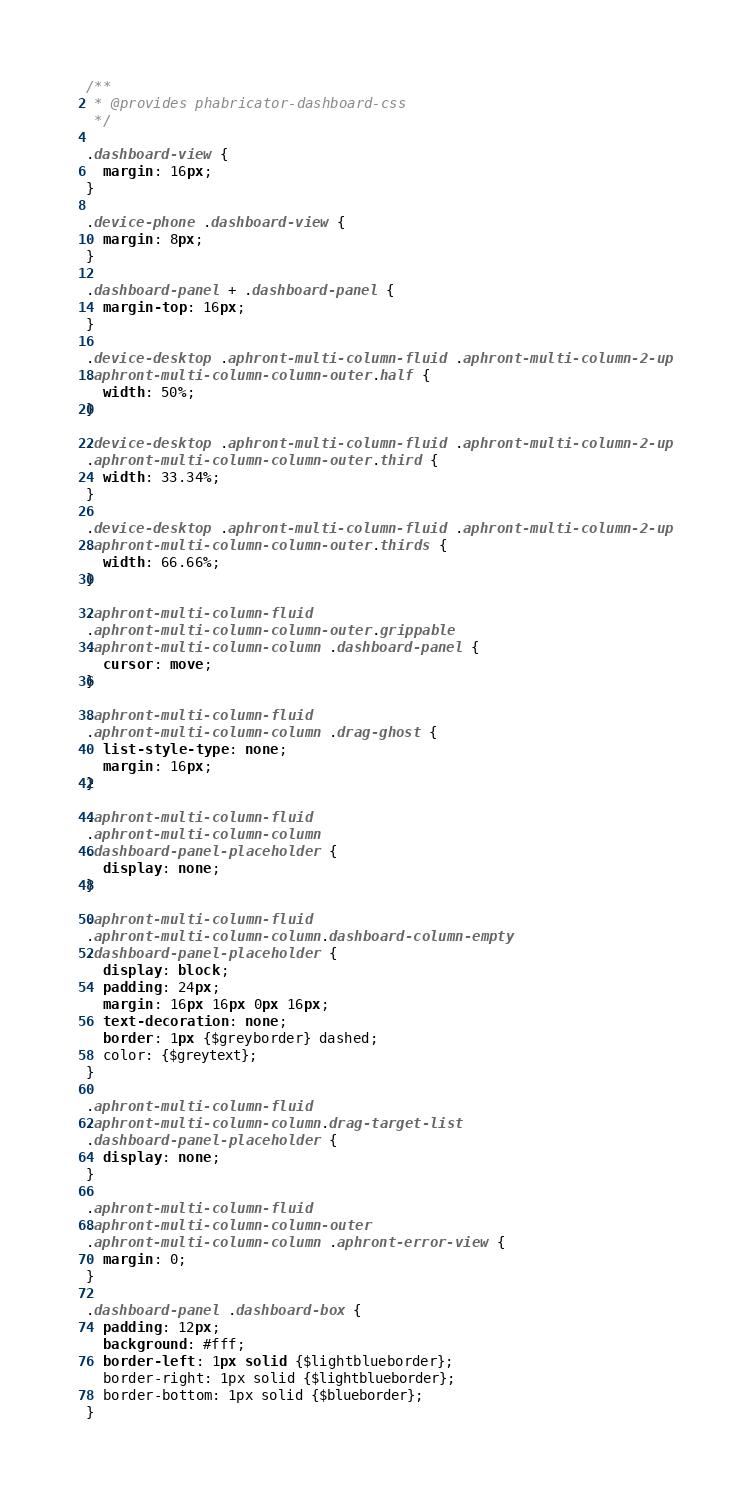<code> <loc_0><loc_0><loc_500><loc_500><_CSS_>/**
 * @provides phabricator-dashboard-css
 */

.dashboard-view {
  margin: 16px;
}

.device-phone .dashboard-view {
  margin: 8px;
}

.dashboard-panel + .dashboard-panel {
  margin-top: 16px;
}

.device-desktop .aphront-multi-column-fluid .aphront-multi-column-2-up
.aphront-multi-column-column-outer.half {
  width: 50%;
}

.device-desktop .aphront-multi-column-fluid .aphront-multi-column-2-up
.aphront-multi-column-column-outer.third {
  width: 33.34%;
}

.device-desktop .aphront-multi-column-fluid .aphront-multi-column-2-up
.aphront-multi-column-column-outer.thirds {
  width: 66.66%;
}

.aphront-multi-column-fluid
.aphront-multi-column-column-outer.grippable
.aphront-multi-column-column .dashboard-panel {
  cursor: move;
}

.aphront-multi-column-fluid
.aphront-multi-column-column .drag-ghost {
  list-style-type: none;
  margin: 16px;
}

.aphront-multi-column-fluid
.aphront-multi-column-column
.dashboard-panel-placeholder {
  display: none;
}

.aphront-multi-column-fluid
.aphront-multi-column-column.dashboard-column-empty
.dashboard-panel-placeholder {
  display: block;
  padding: 24px;
  margin: 16px 16px 0px 16px;
  text-decoration: none;
  border: 1px {$greyborder} dashed;
  color: {$greytext};
}

.aphront-multi-column-fluid
.aphront-multi-column-column.drag-target-list
.dashboard-panel-placeholder {
  display: none;
}

.aphront-multi-column-fluid
.aphront-multi-column-column-outer
.aphront-multi-column-column .aphront-error-view {
  margin: 0;
}

.dashboard-panel .dashboard-box {
  padding: 12px;
  background: #fff;
  border-left: 1px solid {$lightblueborder};
  border-right: 1px solid {$lightblueborder};
  border-bottom: 1px solid {$blueborder};
}
</code> 